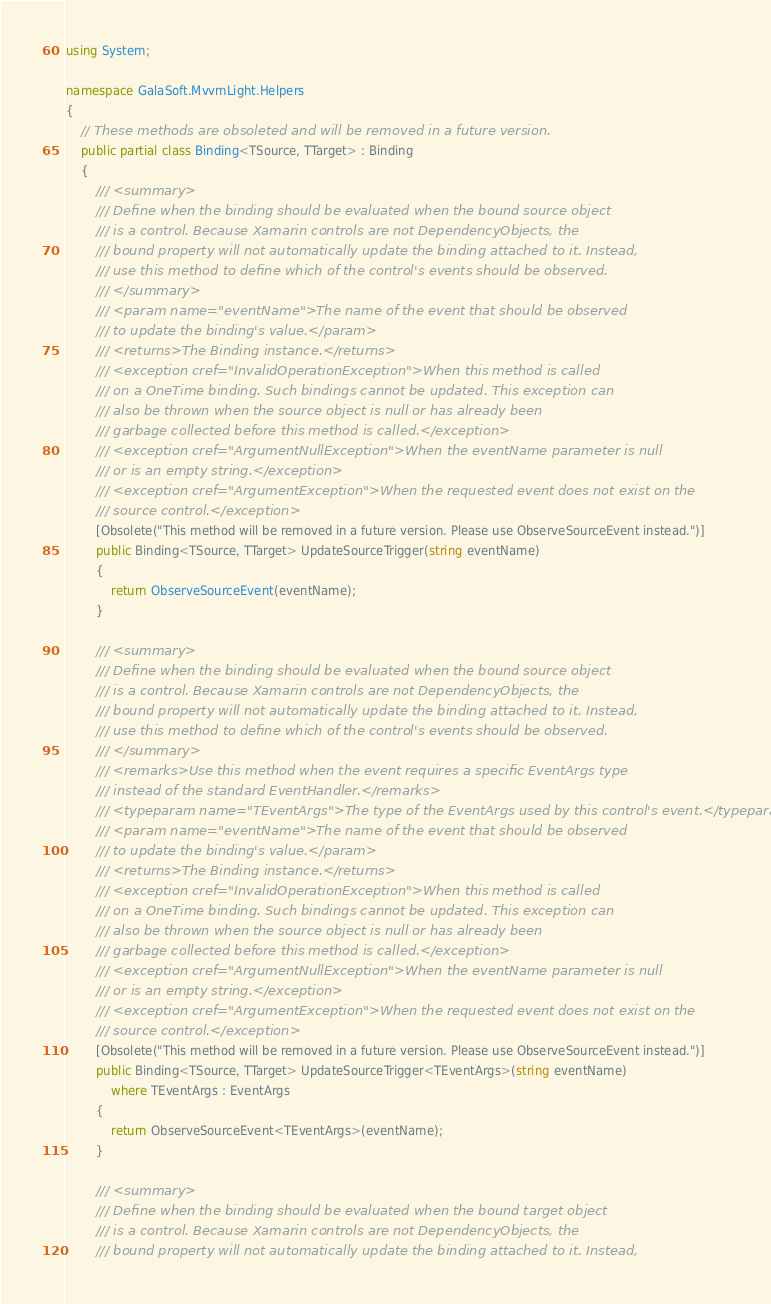Convert code to text. <code><loc_0><loc_0><loc_500><loc_500><_C#_>using System;

namespace GalaSoft.MvvmLight.Helpers
{
    // These methods are obsoleted and will be removed in a future version.
    public partial class Binding<TSource, TTarget> : Binding
    {
        /// <summary>
        /// Define when the binding should be evaluated when the bound source object
        /// is a control. Because Xamarin controls are not DependencyObjects, the
        /// bound property will not automatically update the binding attached to it. Instead,
        /// use this method to define which of the control's events should be observed.
        /// </summary>
        /// <param name="eventName">The name of the event that should be observed
        /// to update the binding's value.</param>
        /// <returns>The Binding instance.</returns>
        /// <exception cref="InvalidOperationException">When this method is called
        /// on a OneTime binding. Such bindings cannot be updated. This exception can
        /// also be thrown when the source object is null or has already been
        /// garbage collected before this method is called.</exception>
        /// <exception cref="ArgumentNullException">When the eventName parameter is null
        /// or is an empty string.</exception>
        /// <exception cref="ArgumentException">When the requested event does not exist on the
        /// source control.</exception>
        [Obsolete("This method will be removed in a future version. Please use ObserveSourceEvent instead.")]
        public Binding<TSource, TTarget> UpdateSourceTrigger(string eventName)
        {
            return ObserveSourceEvent(eventName);
        }

        /// <summary>
        /// Define when the binding should be evaluated when the bound source object
        /// is a control. Because Xamarin controls are not DependencyObjects, the
        /// bound property will not automatically update the binding attached to it. Instead,
        /// use this method to define which of the control's events should be observed.
        /// </summary>
        /// <remarks>Use this method when the event requires a specific EventArgs type
        /// instead of the standard EventHandler.</remarks>
        /// <typeparam name="TEventArgs">The type of the EventArgs used by this control's event.</typeparam>
        /// <param name="eventName">The name of the event that should be observed
        /// to update the binding's value.</param>
        /// <returns>The Binding instance.</returns>
        /// <exception cref="InvalidOperationException">When this method is called
        /// on a OneTime binding. Such bindings cannot be updated. This exception can
        /// also be thrown when the source object is null or has already been
        /// garbage collected before this method is called.</exception>
        /// <exception cref="ArgumentNullException">When the eventName parameter is null
        /// or is an empty string.</exception>
        /// <exception cref="ArgumentException">When the requested event does not exist on the
        /// source control.</exception>
        [Obsolete("This method will be removed in a future version. Please use ObserveSourceEvent instead.")]
        public Binding<TSource, TTarget> UpdateSourceTrigger<TEventArgs>(string eventName)
            where TEventArgs : EventArgs
        {
            return ObserveSourceEvent<TEventArgs>(eventName);
        }

        /// <summary>
        /// Define when the binding should be evaluated when the bound target object
        /// is a control. Because Xamarin controls are not DependencyObjects, the
        /// bound property will not automatically update the binding attached to it. Instead,</code> 